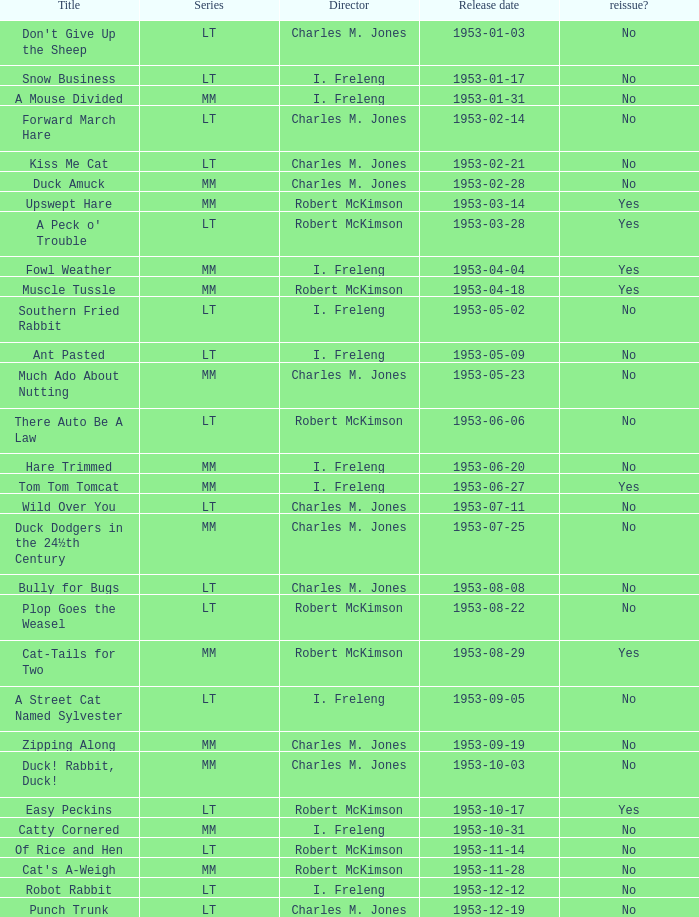Give me the full table as a dictionary. {'header': ['Title', 'Series', 'Director', 'Release date', 'reissue?'], 'rows': [["Don't Give Up the Sheep", 'LT', 'Charles M. Jones', '1953-01-03', 'No'], ['Snow Business', 'LT', 'I. Freleng', '1953-01-17', 'No'], ['A Mouse Divided', 'MM', 'I. Freleng', '1953-01-31', 'No'], ['Forward March Hare', 'LT', 'Charles M. Jones', '1953-02-14', 'No'], ['Kiss Me Cat', 'LT', 'Charles M. Jones', '1953-02-21', 'No'], ['Duck Amuck', 'MM', 'Charles M. Jones', '1953-02-28', 'No'], ['Upswept Hare', 'MM', 'Robert McKimson', '1953-03-14', 'Yes'], ["A Peck o' Trouble", 'LT', 'Robert McKimson', '1953-03-28', 'Yes'], ['Fowl Weather', 'MM', 'I. Freleng', '1953-04-04', 'Yes'], ['Muscle Tussle', 'MM', 'Robert McKimson', '1953-04-18', 'Yes'], ['Southern Fried Rabbit', 'LT', 'I. Freleng', '1953-05-02', 'No'], ['Ant Pasted', 'LT', 'I. Freleng', '1953-05-09', 'No'], ['Much Ado About Nutting', 'MM', 'Charles M. Jones', '1953-05-23', 'No'], ['There Auto Be A Law', 'LT', 'Robert McKimson', '1953-06-06', 'No'], ['Hare Trimmed', 'MM', 'I. Freleng', '1953-06-20', 'No'], ['Tom Tom Tomcat', 'MM', 'I. Freleng', '1953-06-27', 'Yes'], ['Wild Over You', 'LT', 'Charles M. Jones', '1953-07-11', 'No'], ['Duck Dodgers in the 24½th Century', 'MM', 'Charles M. Jones', '1953-07-25', 'No'], ['Bully for Bugs', 'LT', 'Charles M. Jones', '1953-08-08', 'No'], ['Plop Goes the Weasel', 'LT', 'Robert McKimson', '1953-08-22', 'No'], ['Cat-Tails for Two', 'MM', 'Robert McKimson', '1953-08-29', 'Yes'], ['A Street Cat Named Sylvester', 'LT', 'I. Freleng', '1953-09-05', 'No'], ['Zipping Along', 'MM', 'Charles M. Jones', '1953-09-19', 'No'], ['Duck! Rabbit, Duck!', 'MM', 'Charles M. Jones', '1953-10-03', 'No'], ['Easy Peckins', 'LT', 'Robert McKimson', '1953-10-17', 'Yes'], ['Catty Cornered', 'MM', 'I. Freleng', '1953-10-31', 'No'], ['Of Rice and Hen', 'LT', 'Robert McKimson', '1953-11-14', 'No'], ["Cat's A-Weigh", 'MM', 'Robert McKimson', '1953-11-28', 'No'], ['Robot Rabbit', 'LT', 'I. Freleng', '1953-12-12', 'No'], ['Punch Trunk', 'LT', 'Charles M. Jones', '1953-12-19', 'No']]} Was there a reissue of the film released on 1953-10-03? No. 